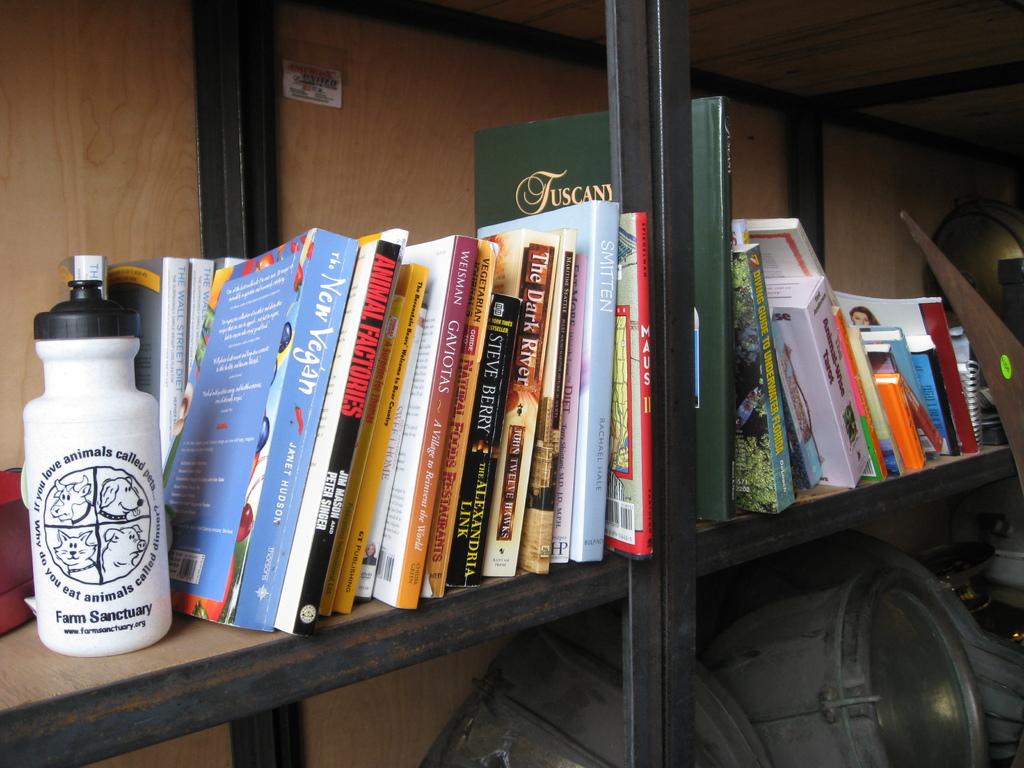What organization is featured on the water bottle?
Keep it short and to the point. Farm sanctuary. 